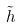<formula> <loc_0><loc_0><loc_500><loc_500>\tilde { h }</formula> 